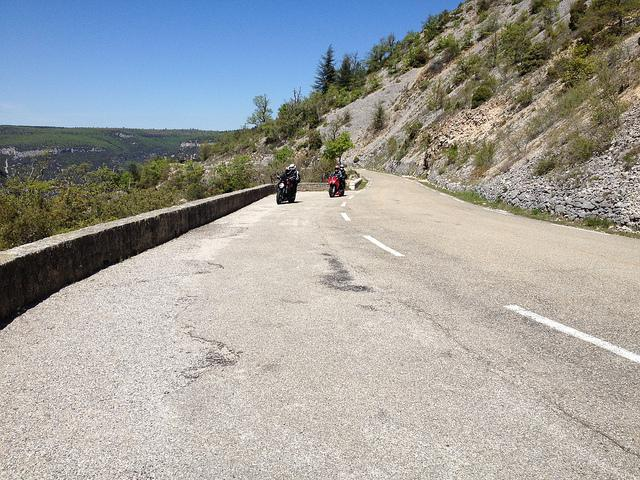What color is the vehicle on the right? Please explain your reasoning. red. The color is red. 